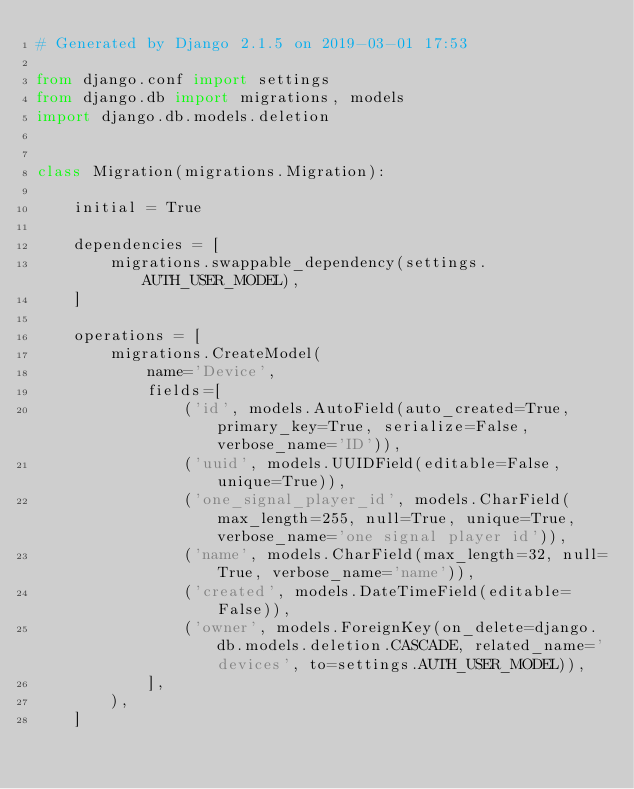Convert code to text. <code><loc_0><loc_0><loc_500><loc_500><_Python_># Generated by Django 2.1.5 on 2019-03-01 17:53

from django.conf import settings
from django.db import migrations, models
import django.db.models.deletion


class Migration(migrations.Migration):

    initial = True

    dependencies = [
        migrations.swappable_dependency(settings.AUTH_USER_MODEL),
    ]

    operations = [
        migrations.CreateModel(
            name='Device',
            fields=[
                ('id', models.AutoField(auto_created=True, primary_key=True, serialize=False, verbose_name='ID')),
                ('uuid', models.UUIDField(editable=False, unique=True)),
                ('one_signal_player_id', models.CharField(max_length=255, null=True, unique=True, verbose_name='one signal player id')),
                ('name', models.CharField(max_length=32, null=True, verbose_name='name')),
                ('created', models.DateTimeField(editable=False)),
                ('owner', models.ForeignKey(on_delete=django.db.models.deletion.CASCADE, related_name='devices', to=settings.AUTH_USER_MODEL)),
            ],
        ),
    ]
</code> 